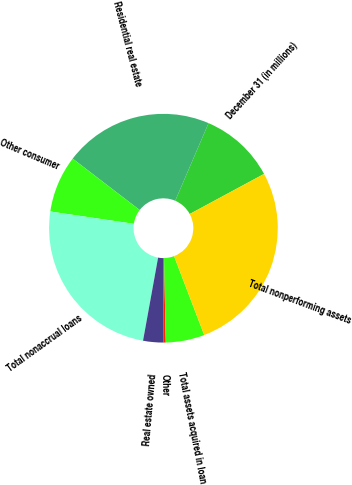<chart> <loc_0><loc_0><loc_500><loc_500><pie_chart><fcel>December 31 (in millions)<fcel>Residential real estate<fcel>Other consumer<fcel>Total nonaccrual loans<fcel>Real estate owned<fcel>Other<fcel>Total assets acquired in loan<fcel>Total nonperforming assets<nl><fcel>10.67%<fcel>21.05%<fcel>8.08%<fcel>24.48%<fcel>2.89%<fcel>0.29%<fcel>5.48%<fcel>27.07%<nl></chart> 